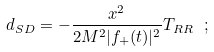<formula> <loc_0><loc_0><loc_500><loc_500>d _ { S D } = - \frac { x ^ { 2 } } { 2 M ^ { 2 } | f _ { + } ( t ) | ^ { 2 } } T _ { R R } \ ;</formula> 